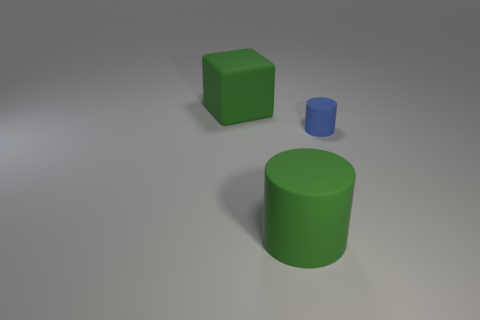Add 1 brown matte cubes. How many objects exist? 4 Subtract all cylinders. How many objects are left? 1 Subtract 0 red cubes. How many objects are left? 3 Subtract all brown spheres. Subtract all blue matte cylinders. How many objects are left? 2 Add 3 big rubber objects. How many big rubber objects are left? 5 Add 1 red metallic objects. How many red metallic objects exist? 1 